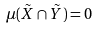<formula> <loc_0><loc_0><loc_500><loc_500>\mu ( \tilde { X } \cap \tilde { Y } ) = 0</formula> 